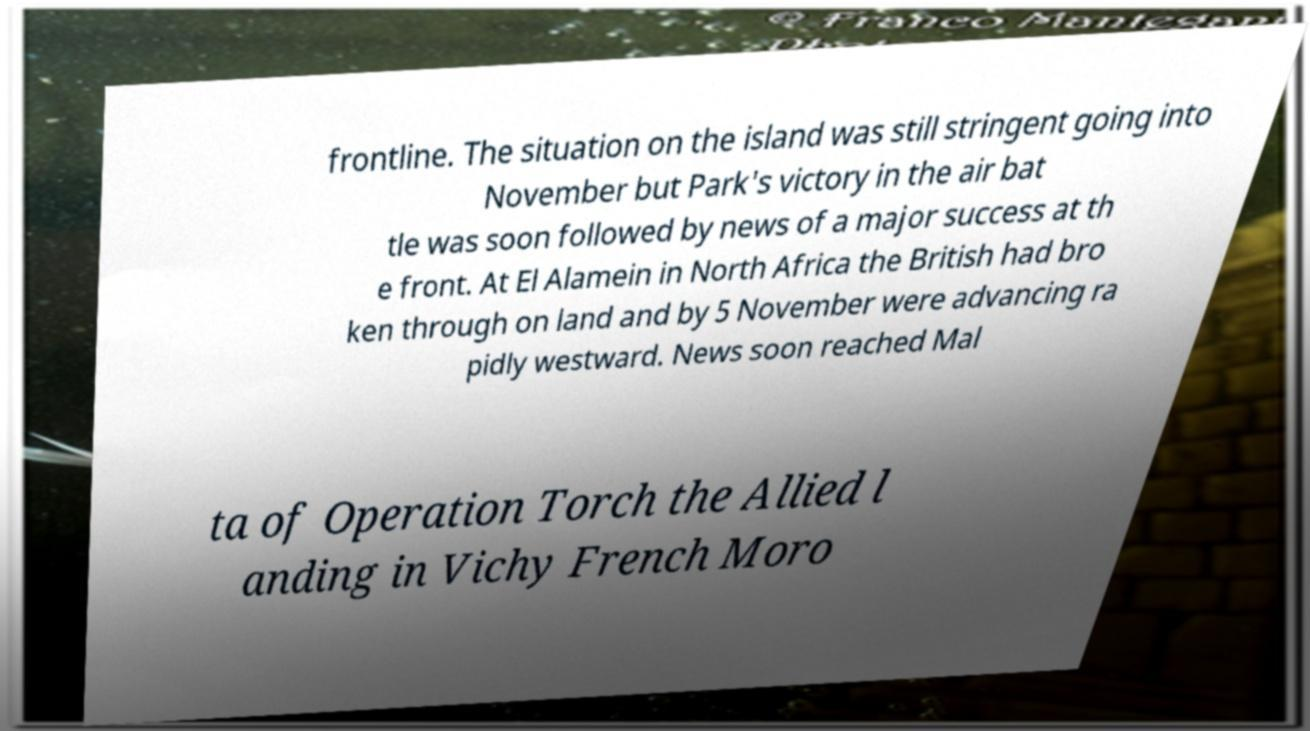Could you assist in decoding the text presented in this image and type it out clearly? frontline. The situation on the island was still stringent going into November but Park's victory in the air bat tle was soon followed by news of a major success at th e front. At El Alamein in North Africa the British had bro ken through on land and by 5 November were advancing ra pidly westward. News soon reached Mal ta of Operation Torch the Allied l anding in Vichy French Moro 